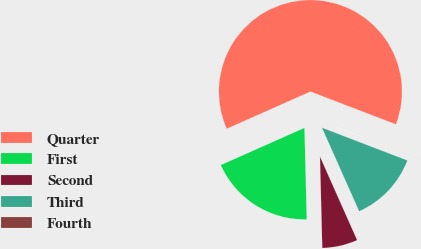Convert chart to OTSL. <chart><loc_0><loc_0><loc_500><loc_500><pie_chart><fcel>Quarter<fcel>First<fcel>Second<fcel>Third<fcel>Fourth<nl><fcel>62.48%<fcel>18.75%<fcel>6.26%<fcel>12.5%<fcel>0.01%<nl></chart> 